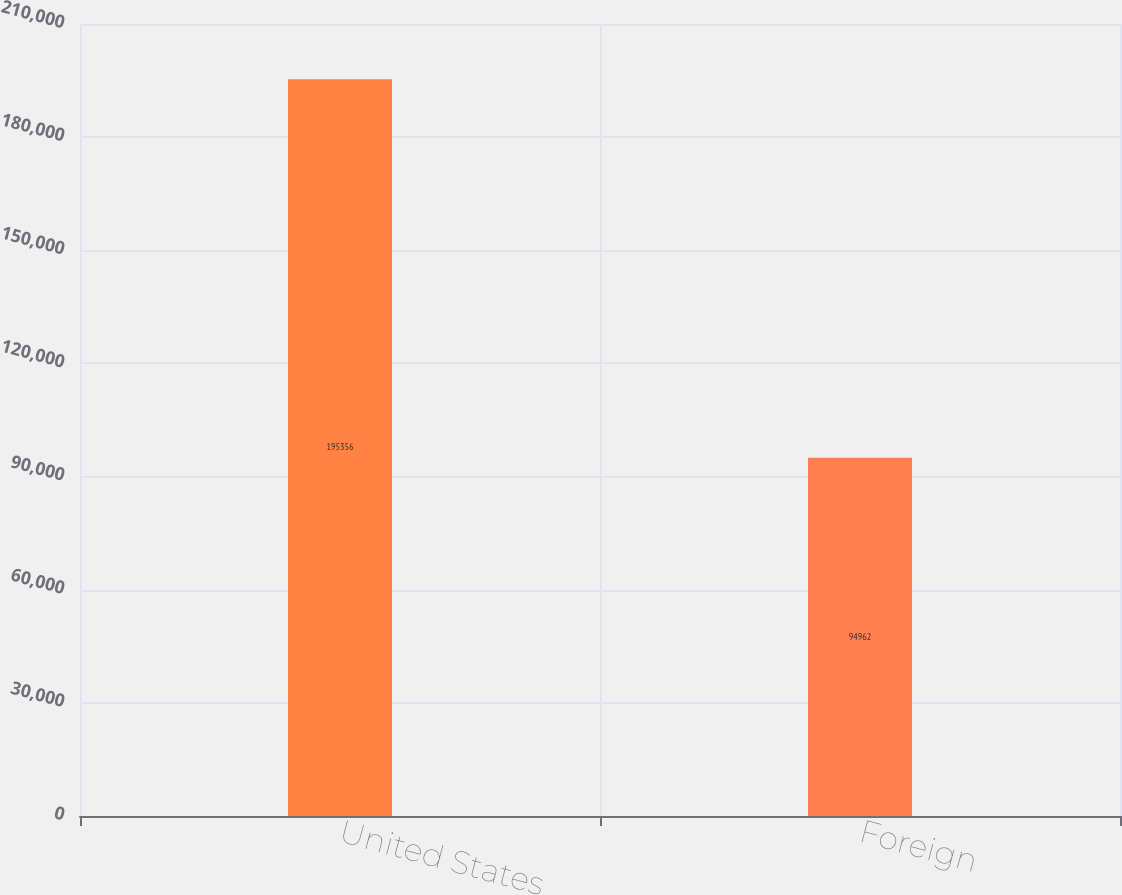<chart> <loc_0><loc_0><loc_500><loc_500><bar_chart><fcel>United States<fcel>Foreign<nl><fcel>195356<fcel>94962<nl></chart> 